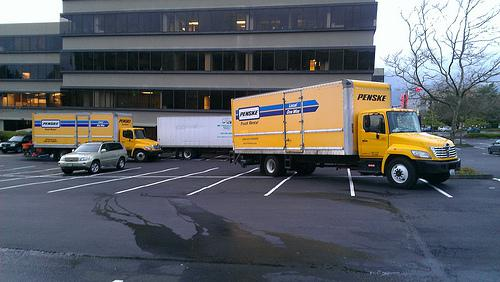Question: where is this scene occurring?
Choices:
A. In a parking lot, outside a building.
B. In a store.
C. In a van.
D. In the woods.
Answer with the letter. Answer: A Question: how is the weather?
Choices:
A. Rainy.
B. Foggy.
C. Snowy.
D. Dry but a little over cast.
Answer with the letter. Answer: D Question: how many trucks can you see in the picture?
Choices:
A. 4.
B. 5.
C. 6.
D. 3.
Answer with the letter. Answer: D Question: what name is on the truck?
Choices:
A. Aaa.
B. Penske.
C. Bob's exterminator.
D. Comcast.
Answer with the letter. Answer: B Question: what can you see behind trucks?
Choices:
A. Phone lines.
B. Stairs.
C. A house.
D. A 3 story building.
Answer with the letter. Answer: D Question: what color are two of the trucks?
Choices:
A. Green.
B. Yellow.
C. Blue.
D. Orange.
Answer with the letter. Answer: B 